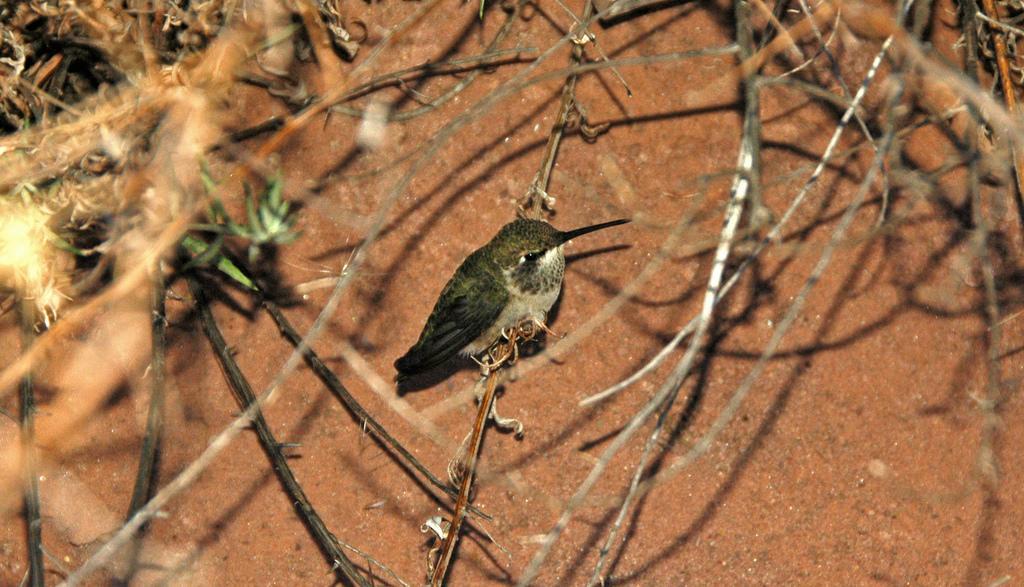Can you describe this image briefly? In the center of the picture there is a bird sitting on a stem. At the top there are twigs. In the background there is soil. It is sunny. 